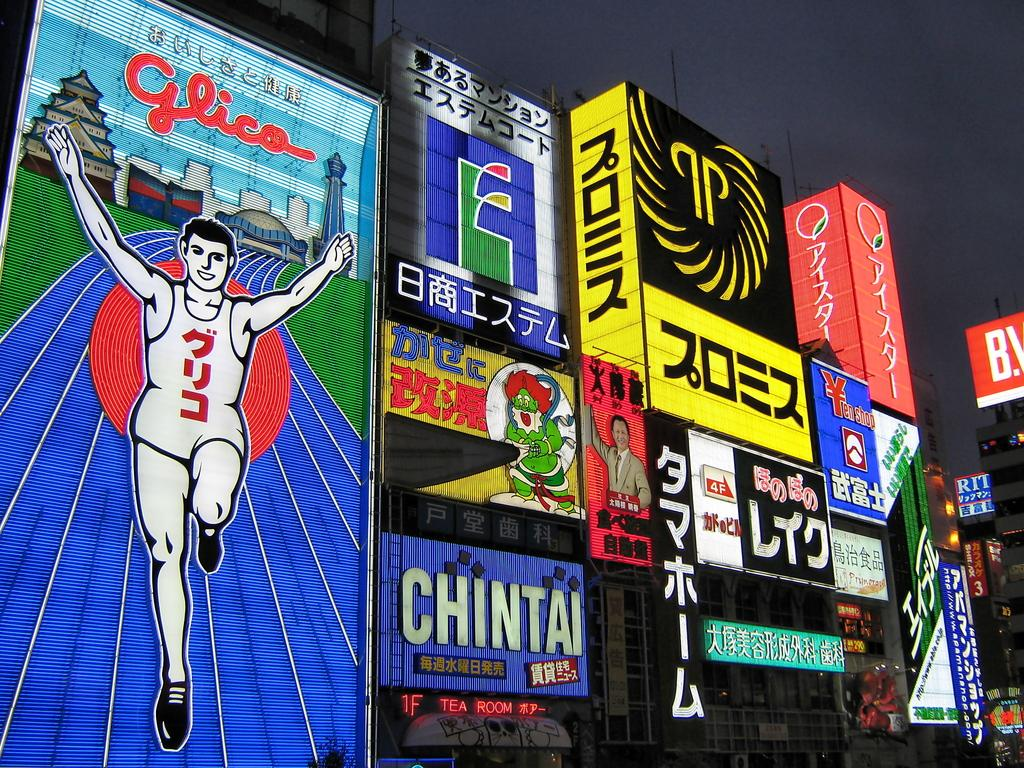<image>
Share a concise interpretation of the image provided. Various advertisements including the Chintai Tea Room and Glica. 